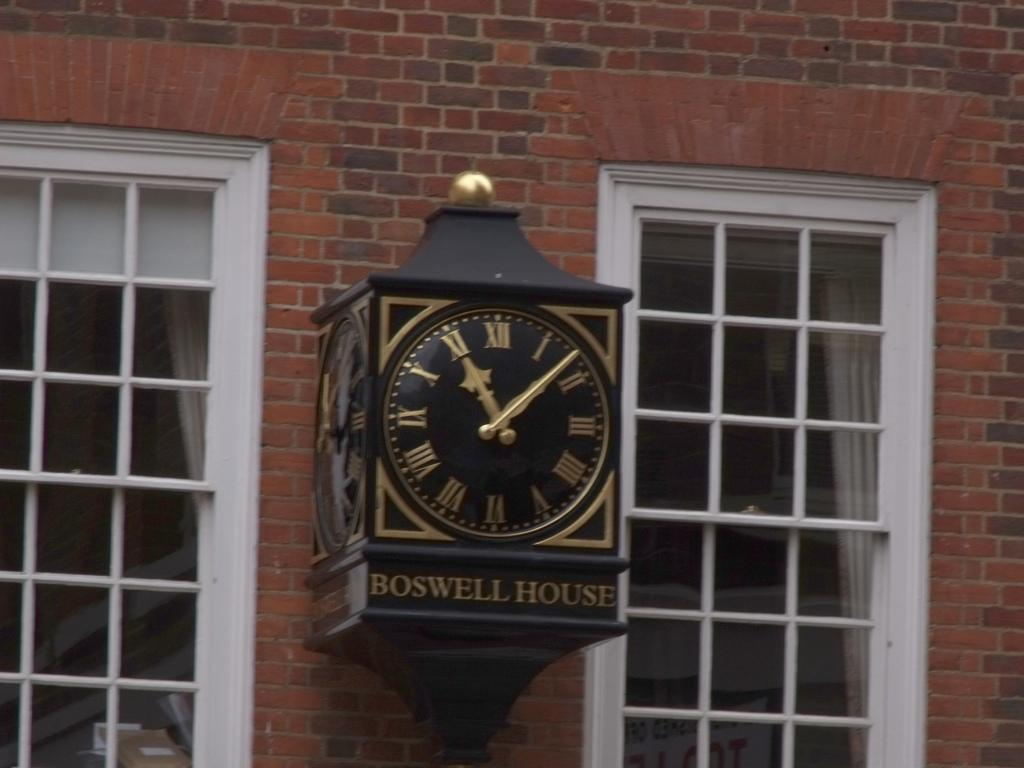<image>
Present a compact description of the photo's key features. On a street clock the words BOSWELL HOUSE are visible. 